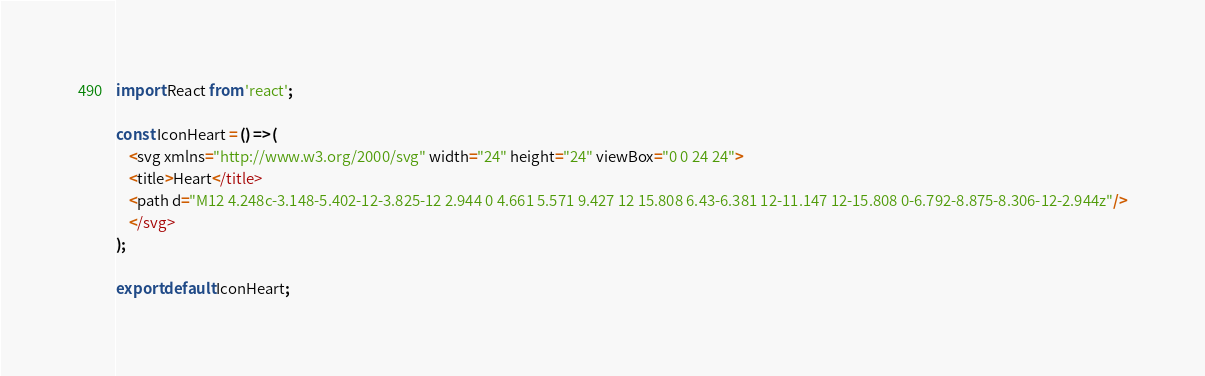Convert code to text. <code><loc_0><loc_0><loc_500><loc_500><_JavaScript_>import React from 'react';

const IconHeart = () => (
    <svg xmlns="http://www.w3.org/2000/svg" width="24" height="24" viewBox="0 0 24 24">
    <title>Heart</title>
    <path d="M12 4.248c-3.148-5.402-12-3.825-12 2.944 0 4.661 5.571 9.427 12 15.808 6.43-6.381 12-11.147 12-15.808 0-6.792-8.875-8.306-12-2.944z"/>
    </svg>
);

export default IconHeart;</code> 